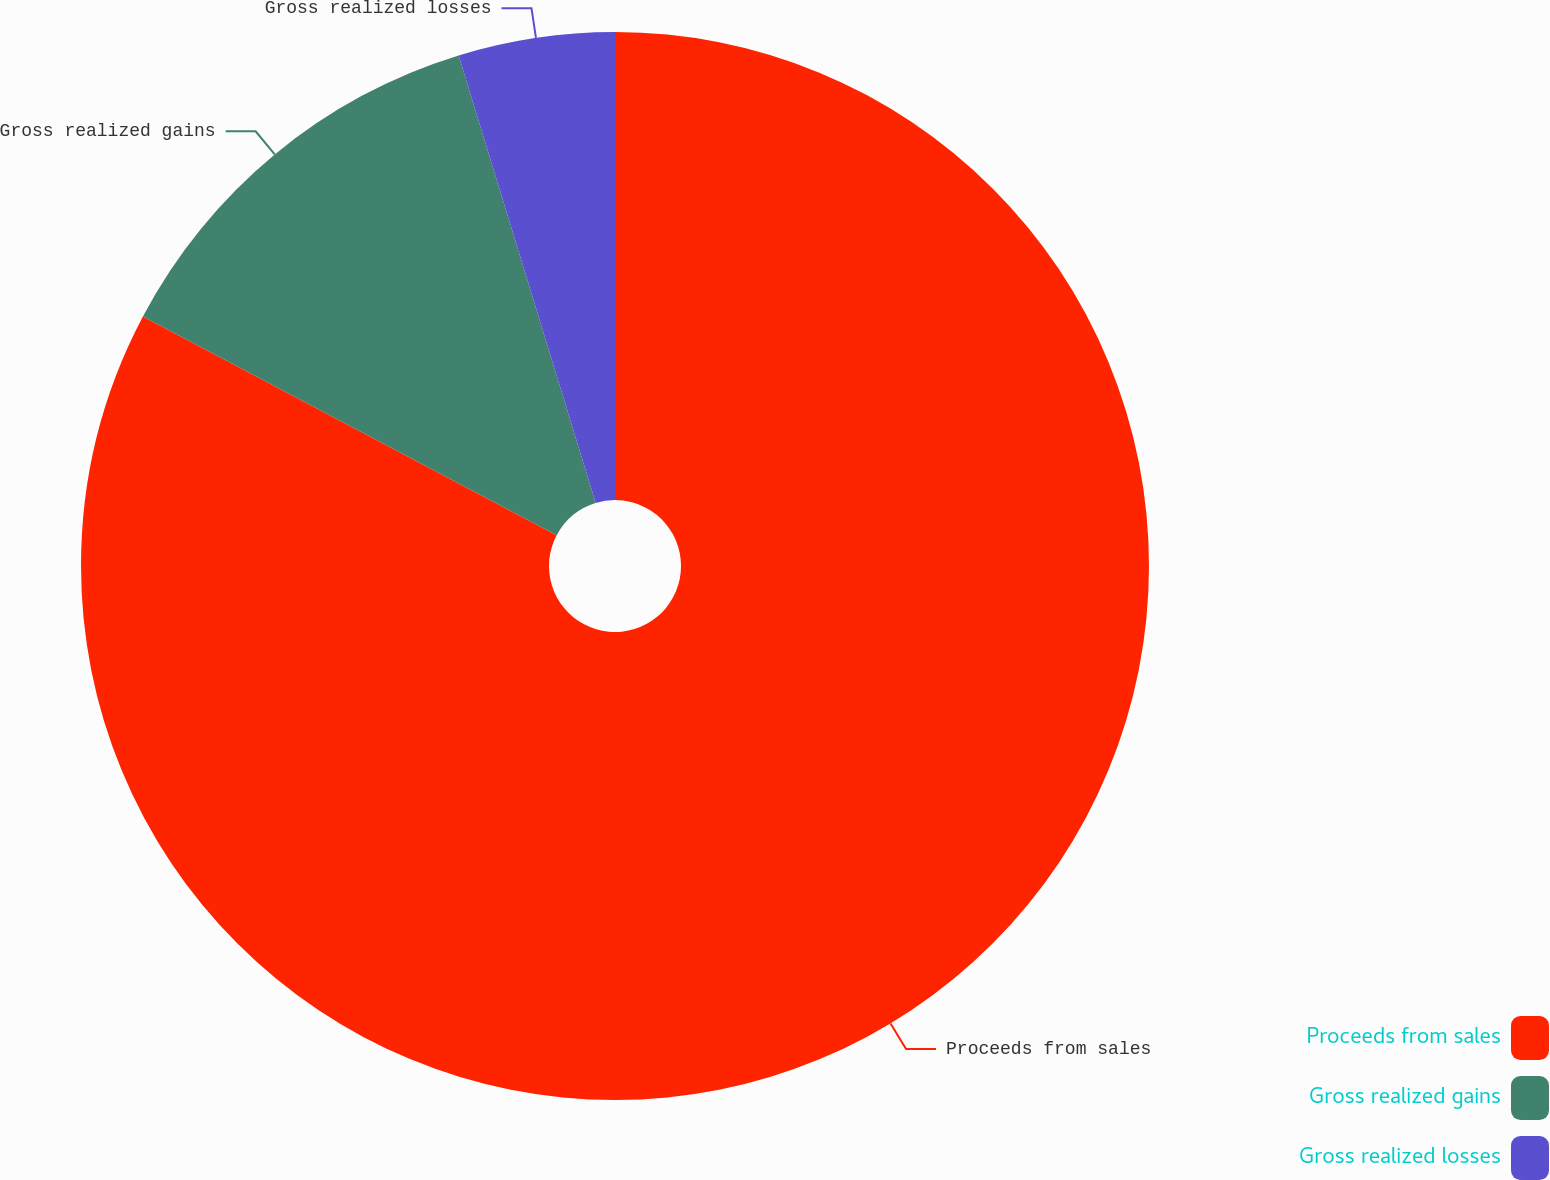Convert chart to OTSL. <chart><loc_0><loc_0><loc_500><loc_500><pie_chart><fcel>Proceeds from sales<fcel>Gross realized gains<fcel>Gross realized losses<nl><fcel>82.74%<fcel>12.53%<fcel>4.73%<nl></chart> 